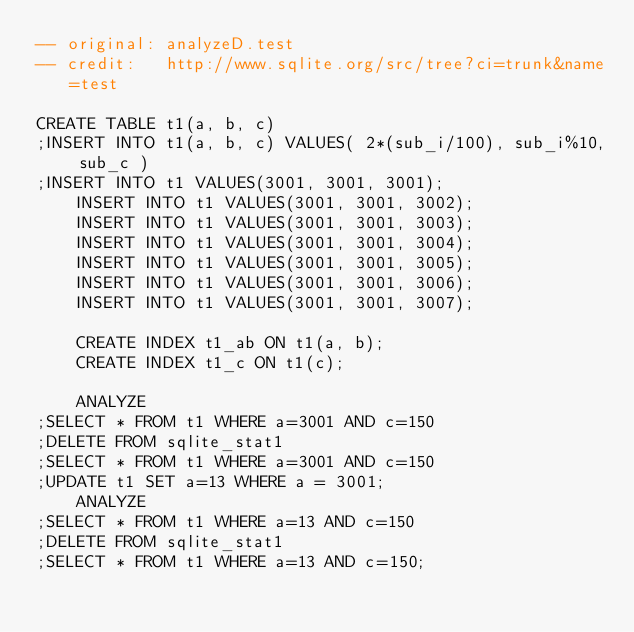<code> <loc_0><loc_0><loc_500><loc_500><_SQL_>-- original: analyzeD.test
-- credit:   http://www.sqlite.org/src/tree?ci=trunk&name=test

CREATE TABLE t1(a, b, c)
;INSERT INTO t1(a, b, c) VALUES( 2*(sub_i/100), sub_i%10, sub_c )
;INSERT INTO t1 VALUES(3001, 3001, 3001);
    INSERT INTO t1 VALUES(3001, 3001, 3002);
    INSERT INTO t1 VALUES(3001, 3001, 3003);
    INSERT INTO t1 VALUES(3001, 3001, 3004);
    INSERT INTO t1 VALUES(3001, 3001, 3005);
    INSERT INTO t1 VALUES(3001, 3001, 3006);
    INSERT INTO t1 VALUES(3001, 3001, 3007);

    CREATE INDEX t1_ab ON t1(a, b);
    CREATE INDEX t1_c ON t1(c);

    ANALYZE
;SELECT * FROM t1 WHERE a=3001 AND c=150
;DELETE FROM sqlite_stat1
;SELECT * FROM t1 WHERE a=3001 AND c=150
;UPDATE t1 SET a=13 WHERE a = 3001;
    ANALYZE
;SELECT * FROM t1 WHERE a=13 AND c=150
;DELETE FROM sqlite_stat1
;SELECT * FROM t1 WHERE a=13 AND c=150;</code> 